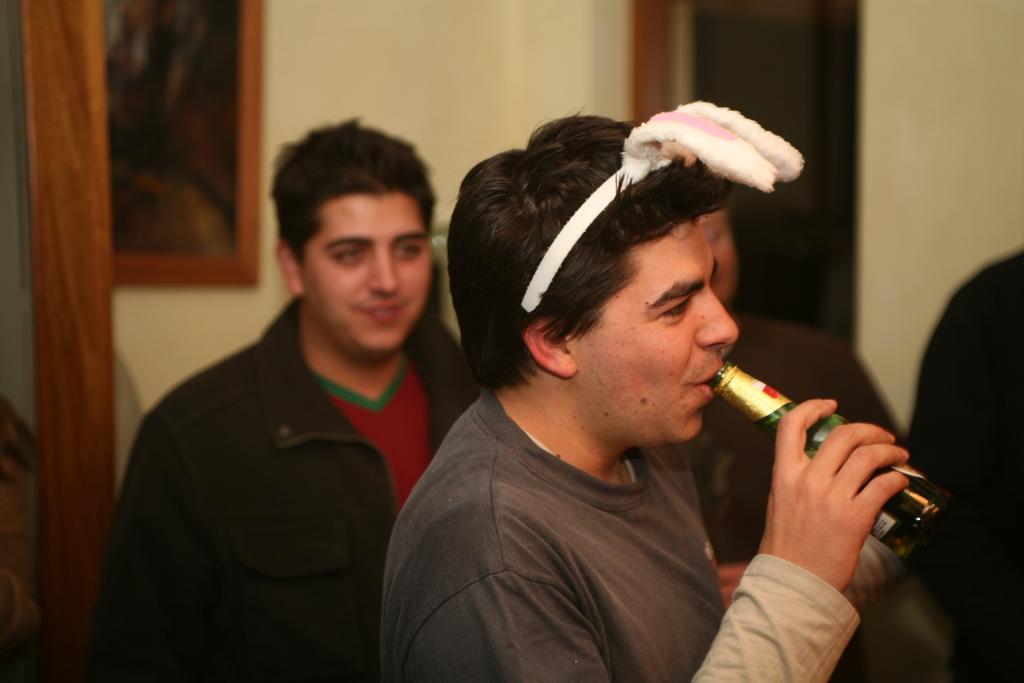In one or two sentences, can you explain what this image depicts? In the image we can see there is a man who is standing and holding wine bottle in his hand. At the back people are standing. 